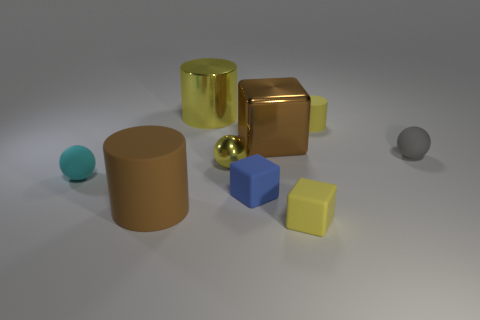Is the number of big brown things that are to the left of the brown shiny block greater than the number of blue objects? After closely examining the image, it appears that there is only one large brown cylindrical object to the left of the shiny brown cube, while there are two blue objects: one blue cube and one small blue sphere. Therefore, the number of big brown things to the left of the brown shiny block is not greater than the number of blue objects. 